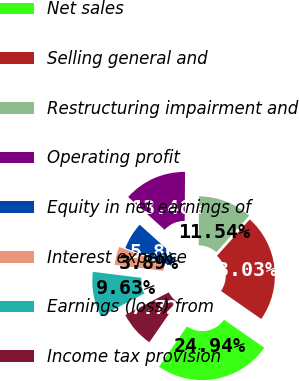Convert chart. <chart><loc_0><loc_0><loc_500><loc_500><pie_chart><fcel>Net sales<fcel>Selling general and<fcel>Restructuring impairment and<fcel>Operating profit<fcel>Equity in net earnings of<fcel>Interest expense<fcel>Earnings (loss) from<fcel>Income tax provision<nl><fcel>24.94%<fcel>23.03%<fcel>11.54%<fcel>13.46%<fcel>5.8%<fcel>3.89%<fcel>9.63%<fcel>7.72%<nl></chart> 